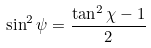Convert formula to latex. <formula><loc_0><loc_0><loc_500><loc_500>\sin ^ { 2 } \psi = \frac { \tan ^ { 2 } \chi - 1 } { 2 }</formula> 